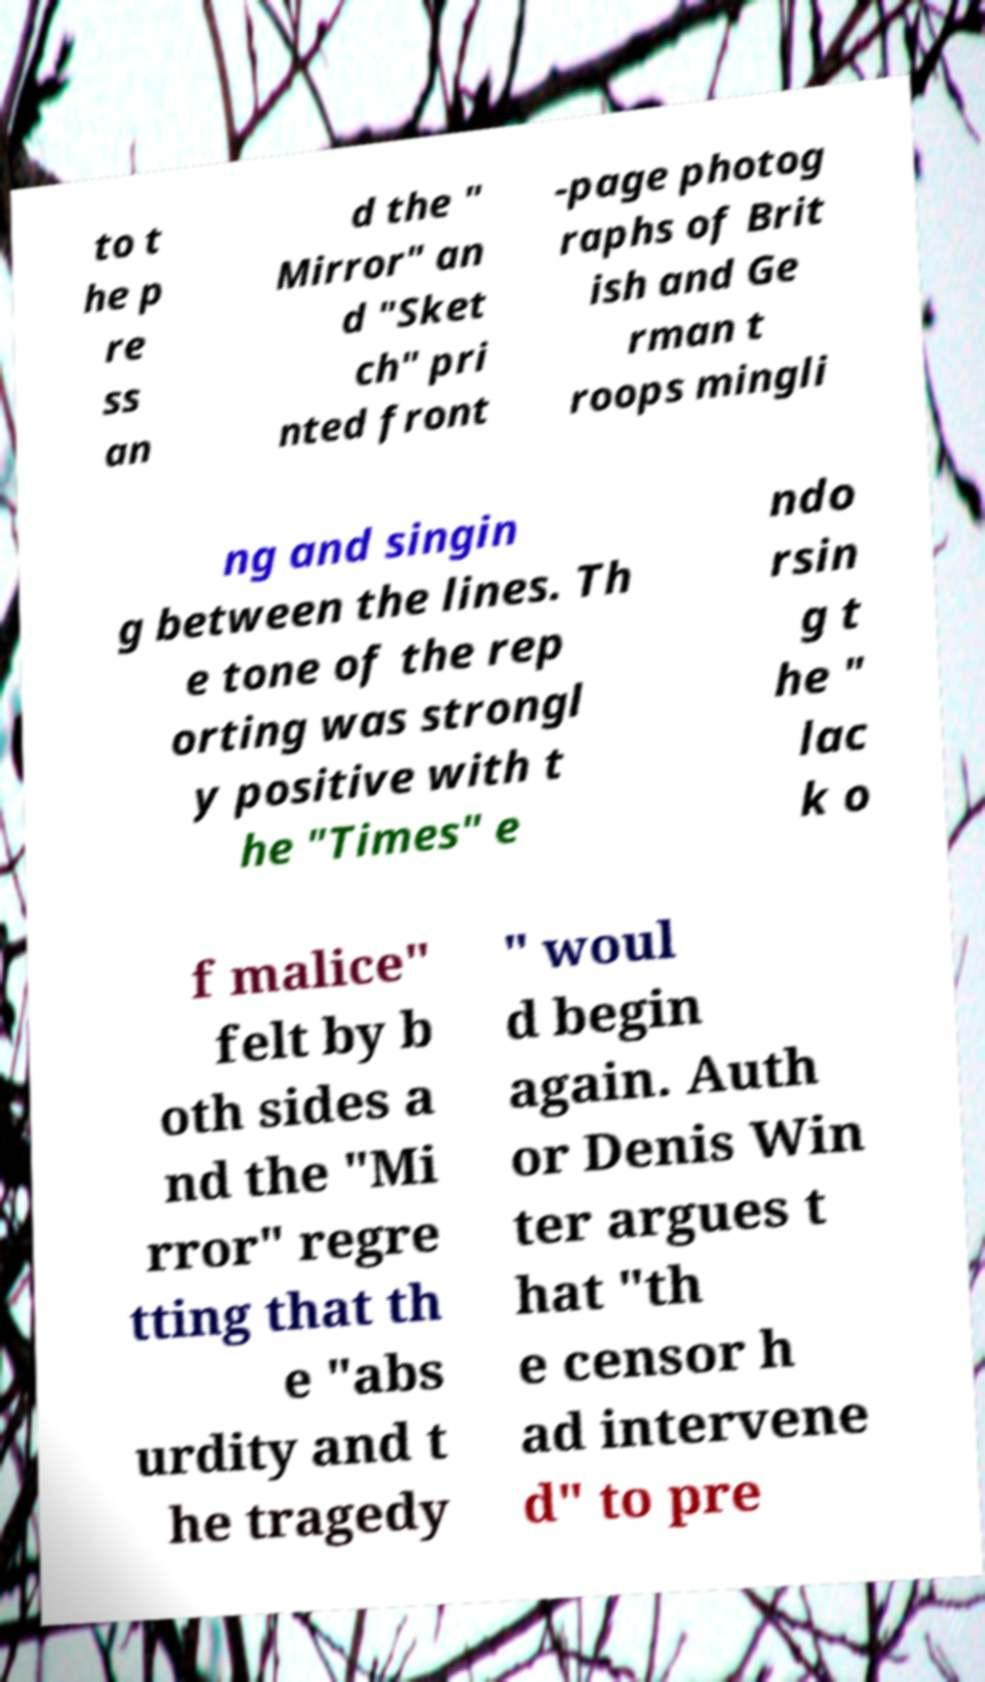I need the written content from this picture converted into text. Can you do that? to t he p re ss an d the " Mirror" an d "Sket ch" pri nted front -page photog raphs of Brit ish and Ge rman t roops mingli ng and singin g between the lines. Th e tone of the rep orting was strongl y positive with t he "Times" e ndo rsin g t he " lac k o f malice" felt by b oth sides a nd the "Mi rror" regre tting that th e "abs urdity and t he tragedy " woul d begin again. Auth or Denis Win ter argues t hat "th e censor h ad intervene d" to pre 